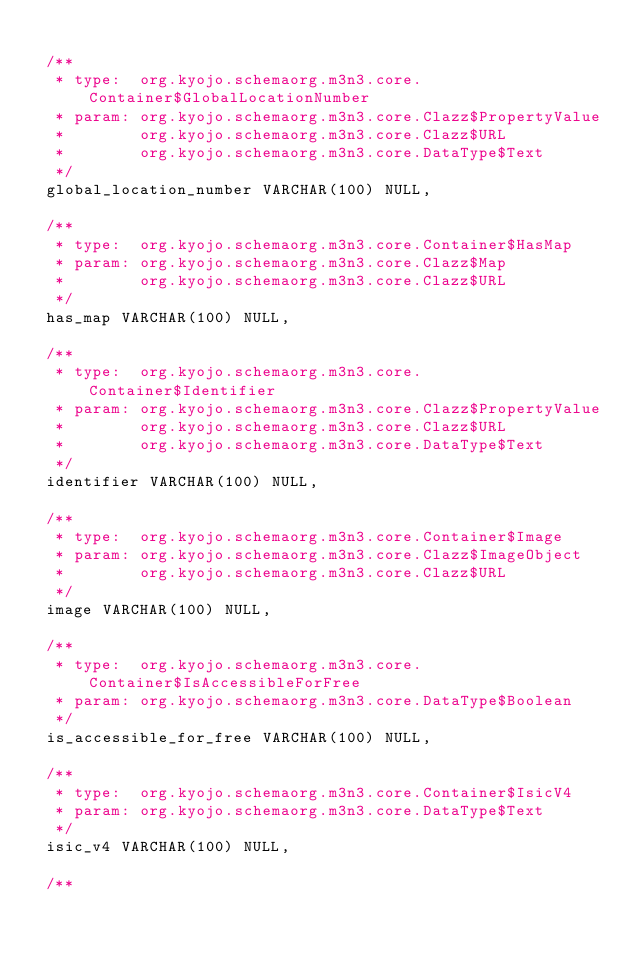<code> <loc_0><loc_0><loc_500><loc_500><_SQL_>
 /**
  * type:  org.kyojo.schemaorg.m3n3.core.Container$GlobalLocationNumber
  * param: org.kyojo.schemaorg.m3n3.core.Clazz$PropertyValue
  *        org.kyojo.schemaorg.m3n3.core.Clazz$URL
  *        org.kyojo.schemaorg.m3n3.core.DataType$Text
  */
 global_location_number VARCHAR(100) NULL,

 /**
  * type:  org.kyojo.schemaorg.m3n3.core.Container$HasMap
  * param: org.kyojo.schemaorg.m3n3.core.Clazz$Map
  *        org.kyojo.schemaorg.m3n3.core.Clazz$URL
  */
 has_map VARCHAR(100) NULL,

 /**
  * type:  org.kyojo.schemaorg.m3n3.core.Container$Identifier
  * param: org.kyojo.schemaorg.m3n3.core.Clazz$PropertyValue
  *        org.kyojo.schemaorg.m3n3.core.Clazz$URL
  *        org.kyojo.schemaorg.m3n3.core.DataType$Text
  */
 identifier VARCHAR(100) NULL,

 /**
  * type:  org.kyojo.schemaorg.m3n3.core.Container$Image
  * param: org.kyojo.schemaorg.m3n3.core.Clazz$ImageObject
  *        org.kyojo.schemaorg.m3n3.core.Clazz$URL
  */
 image VARCHAR(100) NULL,

 /**
  * type:  org.kyojo.schemaorg.m3n3.core.Container$IsAccessibleForFree
  * param: org.kyojo.schemaorg.m3n3.core.DataType$Boolean
  */
 is_accessible_for_free VARCHAR(100) NULL,

 /**
  * type:  org.kyojo.schemaorg.m3n3.core.Container$IsicV4
  * param: org.kyojo.schemaorg.m3n3.core.DataType$Text
  */
 isic_v4 VARCHAR(100) NULL,

 /**</code> 